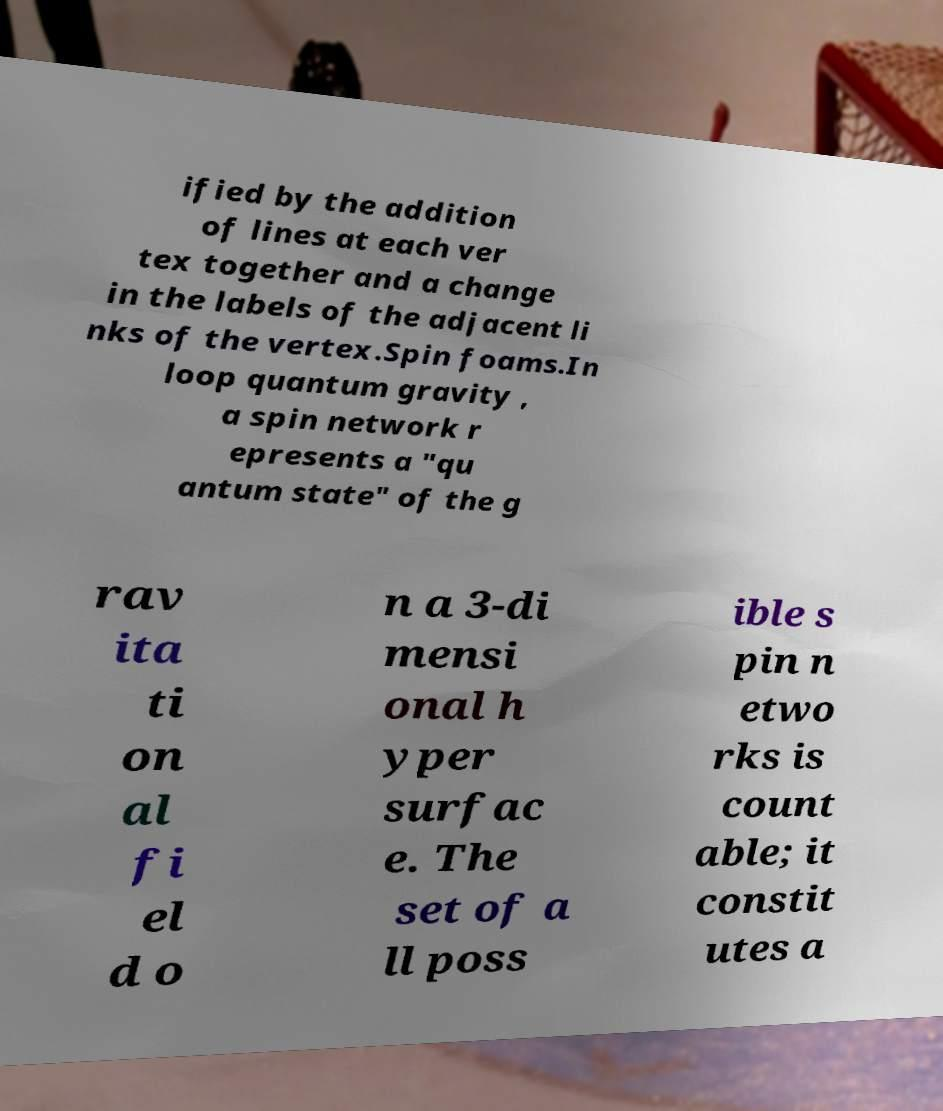Could you extract and type out the text from this image? ified by the addition of lines at each ver tex together and a change in the labels of the adjacent li nks of the vertex.Spin foams.In loop quantum gravity , a spin network r epresents a "qu antum state" of the g rav ita ti on al fi el d o n a 3-di mensi onal h yper surfac e. The set of a ll poss ible s pin n etwo rks is count able; it constit utes a 